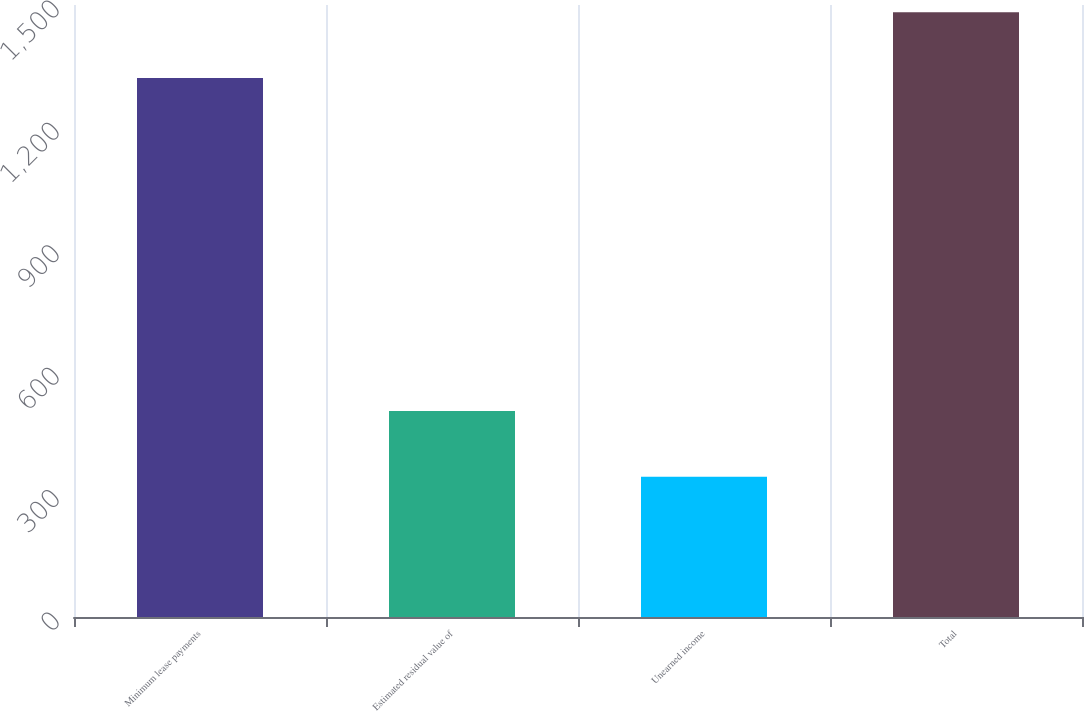<chart> <loc_0><loc_0><loc_500><loc_500><bar_chart><fcel>Minimum lease payments<fcel>Estimated residual value of<fcel>Unearned income<fcel>Total<nl><fcel>1321<fcel>505<fcel>344<fcel>1482<nl></chart> 